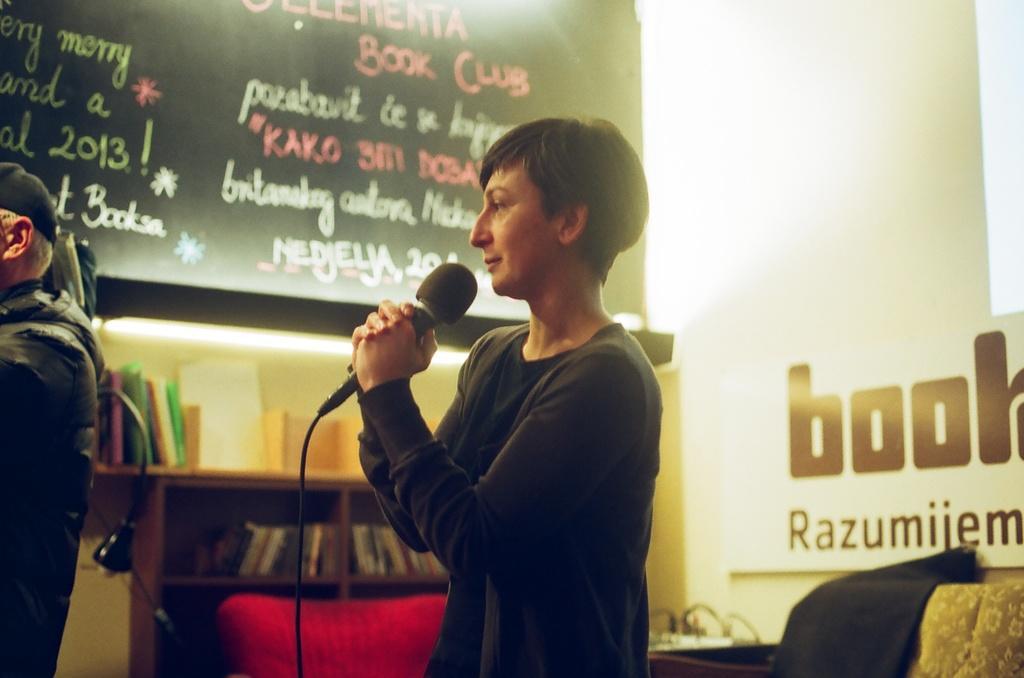Please provide a concise description of this image. In this image I can see a person holding the mic. In front of him there is another person standing. To the right of him there a board and the books inside the cupboard. 